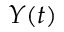Convert formula to latex. <formula><loc_0><loc_0><loc_500><loc_500>Y ( t )</formula> 